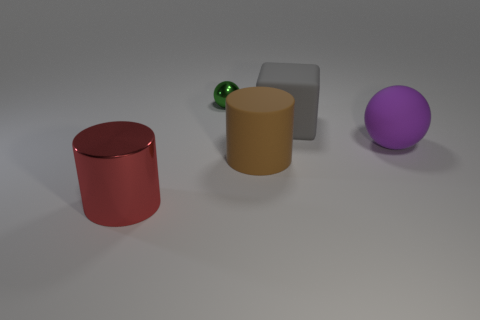Do the big thing that is behind the purple object and the purple sphere have the same material?
Your answer should be compact. Yes. How many cylinders are either large gray matte things or brown objects?
Make the answer very short. 1. The large thing that is both left of the large gray object and behind the red metal thing has what shape?
Offer a very short reply. Cylinder. There is a cylinder in front of the big cylinder to the right of the big object that is to the left of the green shiny thing; what color is it?
Keep it short and to the point. Red. Are there fewer green metallic spheres left of the big purple object than tiny gray metal blocks?
Give a very brief answer. No. There is a shiny object that is behind the brown rubber cylinder; does it have the same shape as the thing that is in front of the large rubber cylinder?
Your response must be concise. No. What number of things are either objects behind the red object or objects?
Give a very brief answer. 5. There is a large object that is left of the object that is behind the rubber block; are there any brown rubber things that are on the left side of it?
Provide a succinct answer. No. Is the number of matte cubes that are on the right side of the large block less than the number of red cylinders that are on the right side of the large brown matte cylinder?
Provide a short and direct response. No. What color is the cylinder that is the same material as the small object?
Keep it short and to the point. Red. 